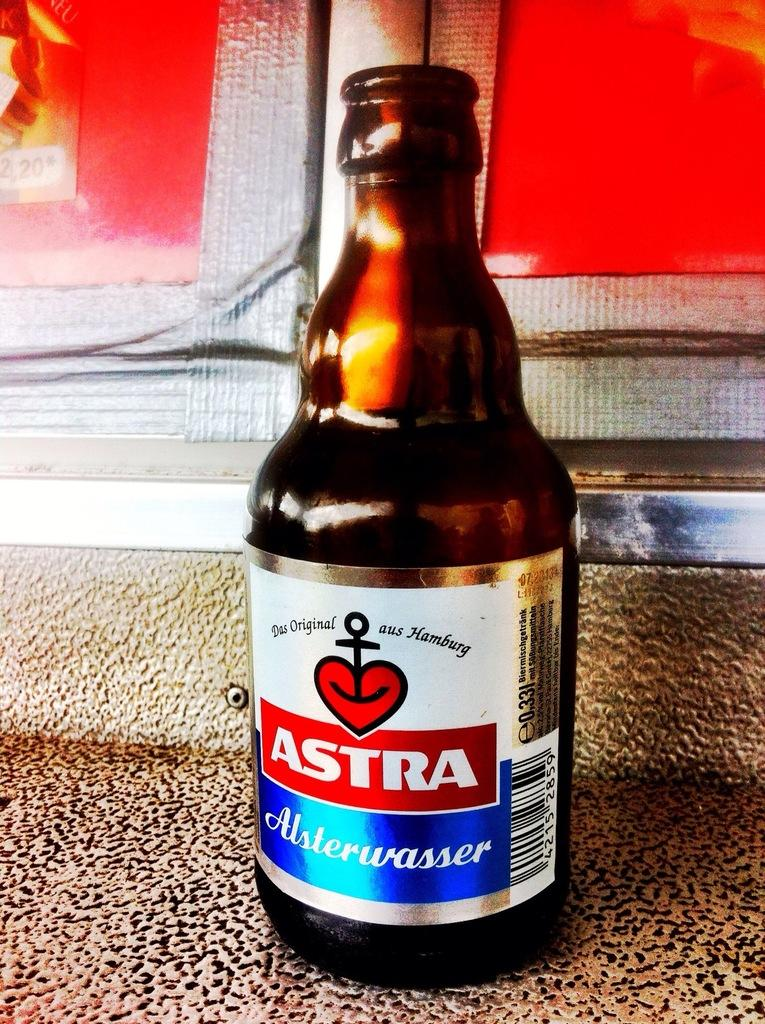<image>
Relay a brief, clear account of the picture shown. A brown bottle with a label stating it as Das Original Aus Hamburg. 